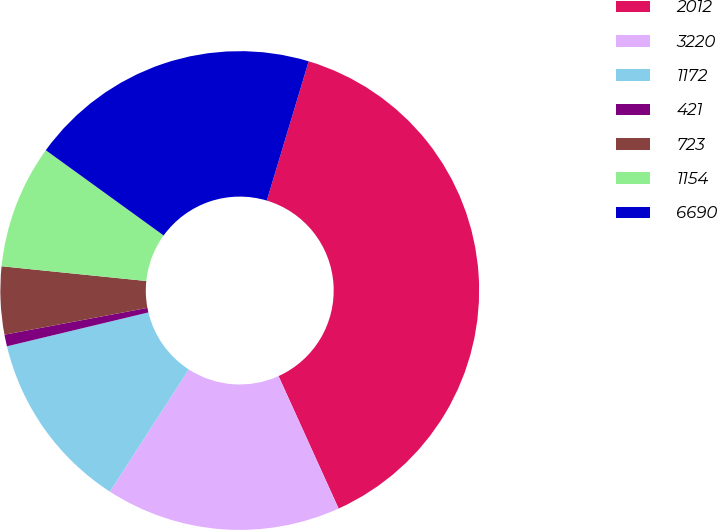Convert chart to OTSL. <chart><loc_0><loc_0><loc_500><loc_500><pie_chart><fcel>2012<fcel>3220<fcel>1172<fcel>421<fcel>723<fcel>1154<fcel>6690<nl><fcel>38.57%<fcel>15.9%<fcel>12.13%<fcel>0.79%<fcel>4.57%<fcel>8.35%<fcel>19.68%<nl></chart> 